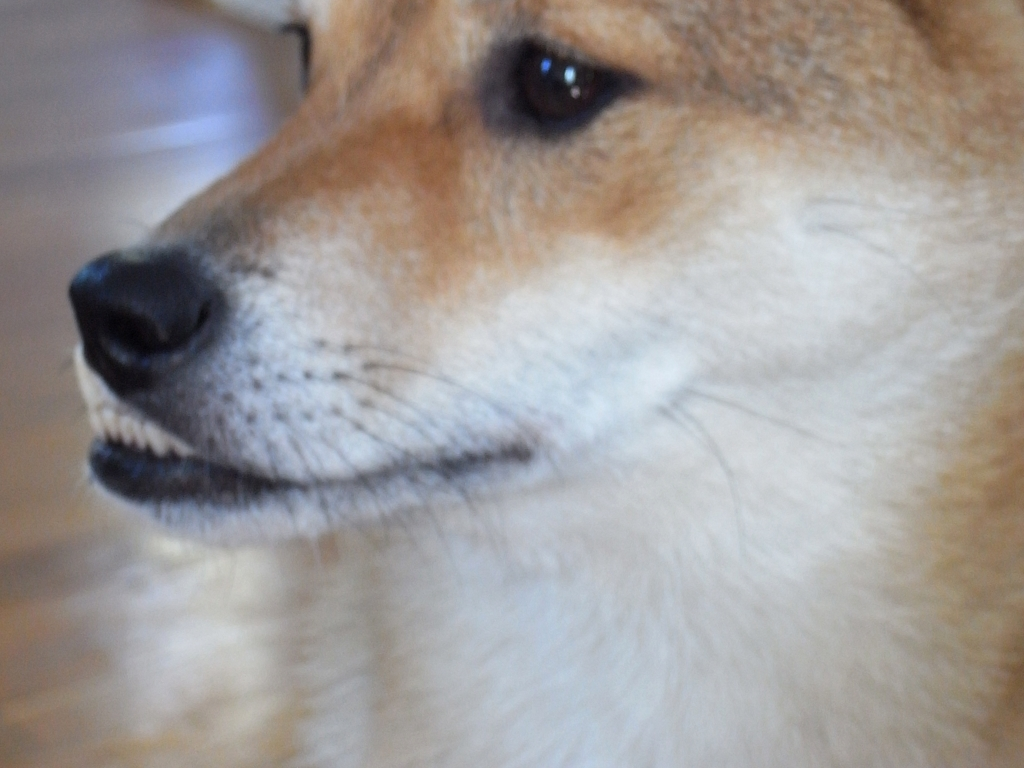Can you describe the subject of this photo? Certainly! The image features a close-up portrait of a dog. The dog has a short, dense fur coat that appears to be in shades of tan and white. Its eyes are attentive and expressive, indicative of its focus or interest in something out of frame. The detail allows us to appreciate the texture of the dog's fur and the subtleties of its coloration. 